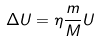Convert formula to latex. <formula><loc_0><loc_0><loc_500><loc_500>\Delta U = \eta \frac { m } { M } U</formula> 